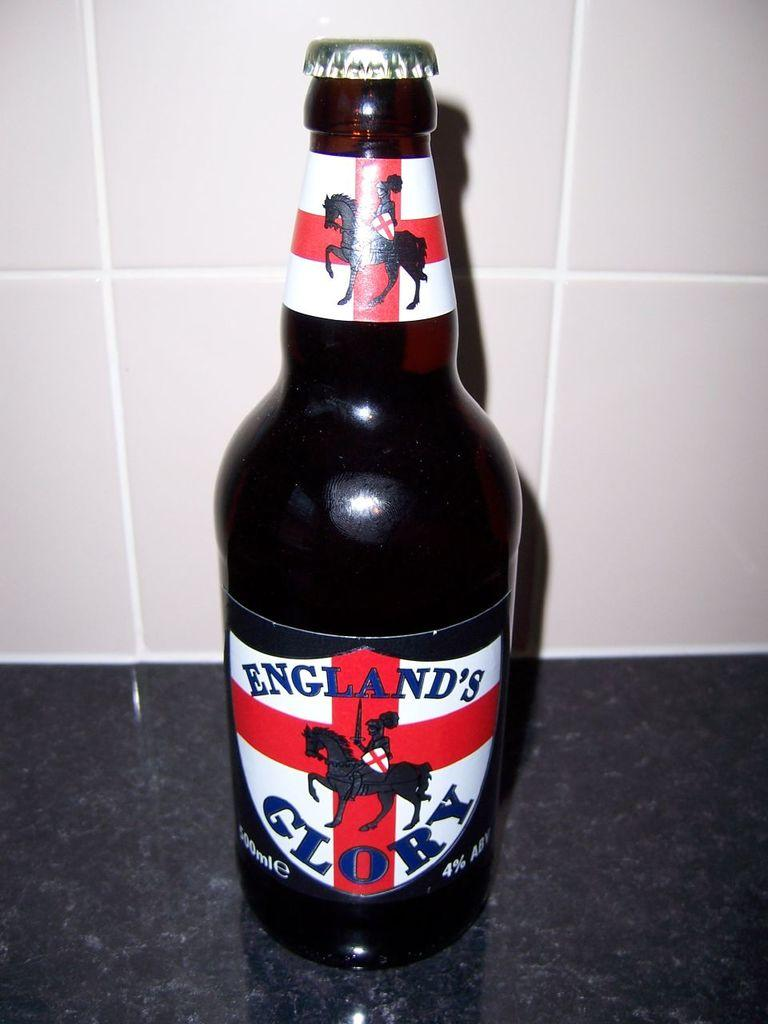Provide a one-sentence caption for the provided image. A black bottle that is by a brand called England's Glory. 